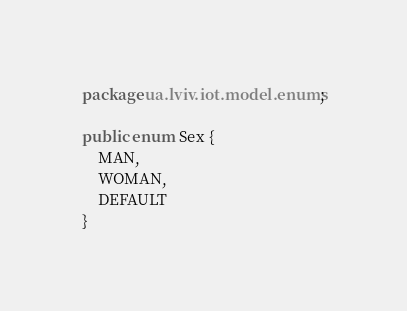<code> <loc_0><loc_0><loc_500><loc_500><_Java_>package ua.lviv.iot.model.enums;

public enum Sex {
    MAN,
    WOMAN,
    DEFAULT
}
</code> 